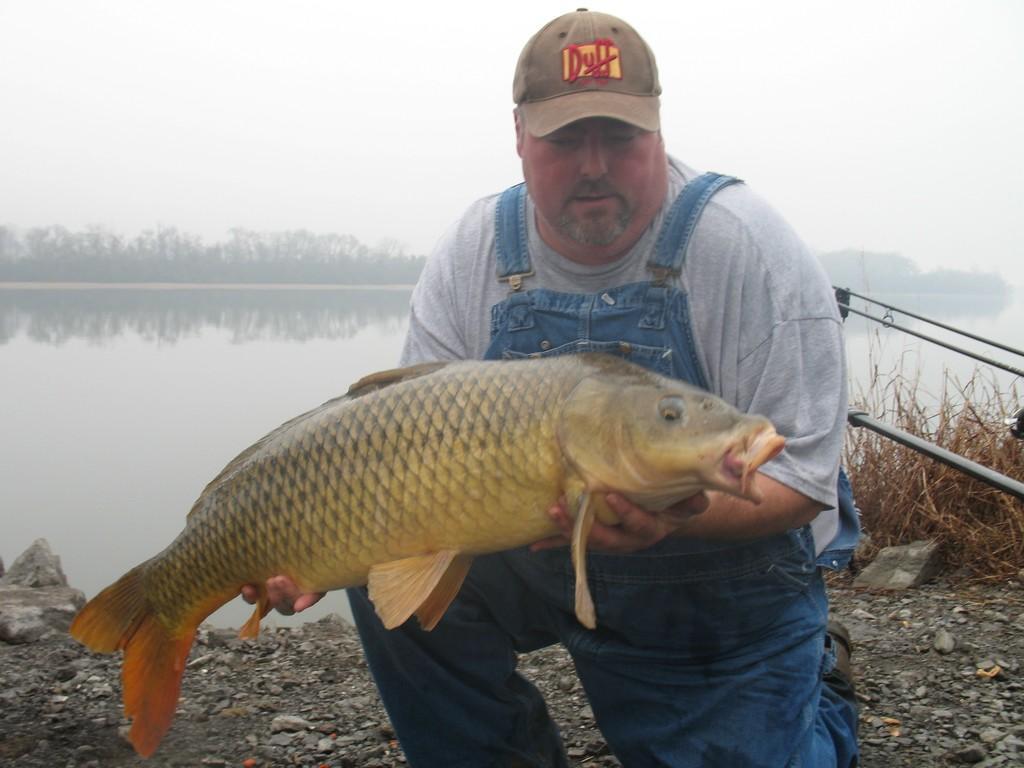Describe this image in one or two sentences. In this picture we can see a man wore a cap and holding a fish with his hands and at the back of him we can see stones on the ground, plants, water, rods and in the background we can see the sky. 